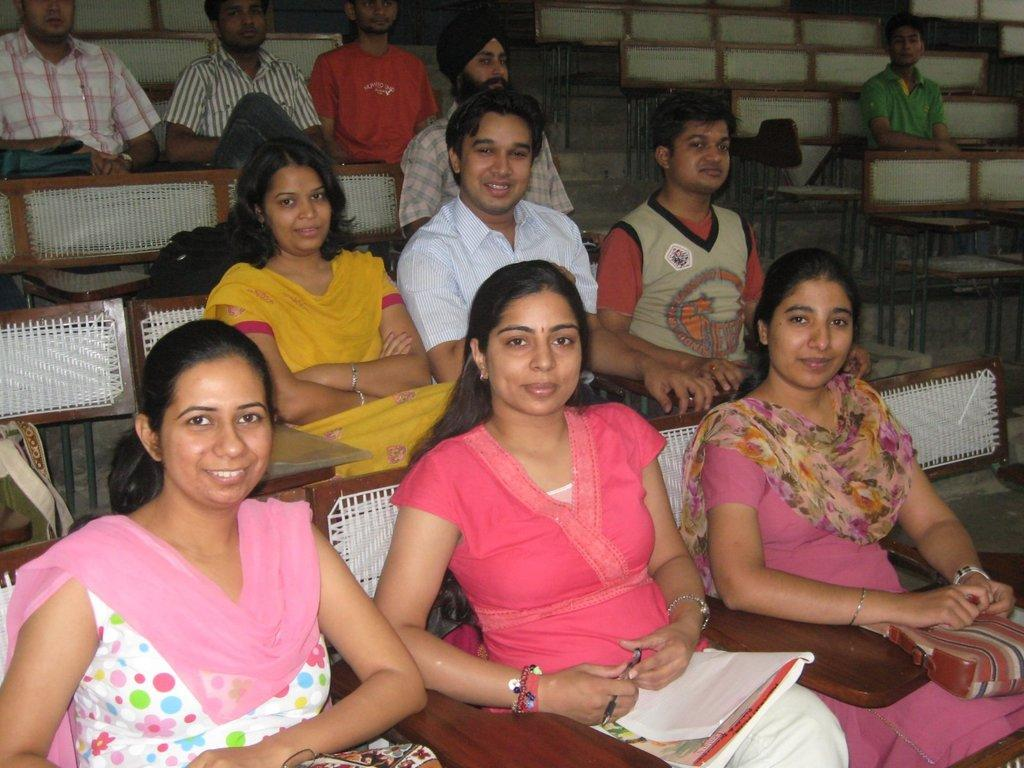What is the general setting of the image? There is a group of people sitting in the image. Can you describe the attire of one of the individuals? One person is wearing a pink and white dress. What object is being held by one of the people in the image? Another person is holding a pen. What type of item can be seen in the image that might be used for reading or learning? A book is visible in the image. What type of crack can be seen in the image? There is no crack present in the image. Is there a fire visible in the image? No, there is no fire visible in the image. 